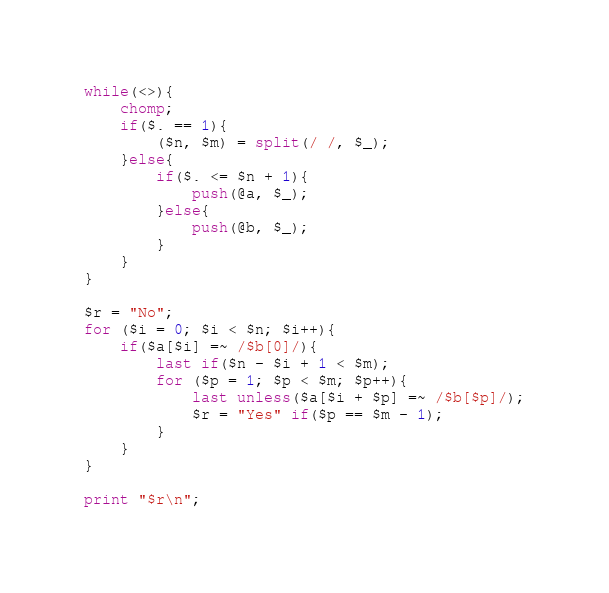Convert code to text. <code><loc_0><loc_0><loc_500><loc_500><_Perl_>while(<>){
	chomp;
	if($. == 1){
		($n, $m) = split(/ /, $_);
	}else{
		if($. <= $n + 1){
			push(@a, $_);
		}else{
			push(@b, $_);
		}
	}
}

$r = "No";
for ($i = 0; $i < $n; $i++){
	if($a[$i] =~ /$b[0]/){
		last if($n - $i + 1 < $m);
		for ($p = 1; $p < $m; $p++){
			last unless($a[$i + $p] =~ /$b[$p]/);
			$r = "Yes" if($p == $m - 1);
		}
	}
}

print "$r\n";
</code> 